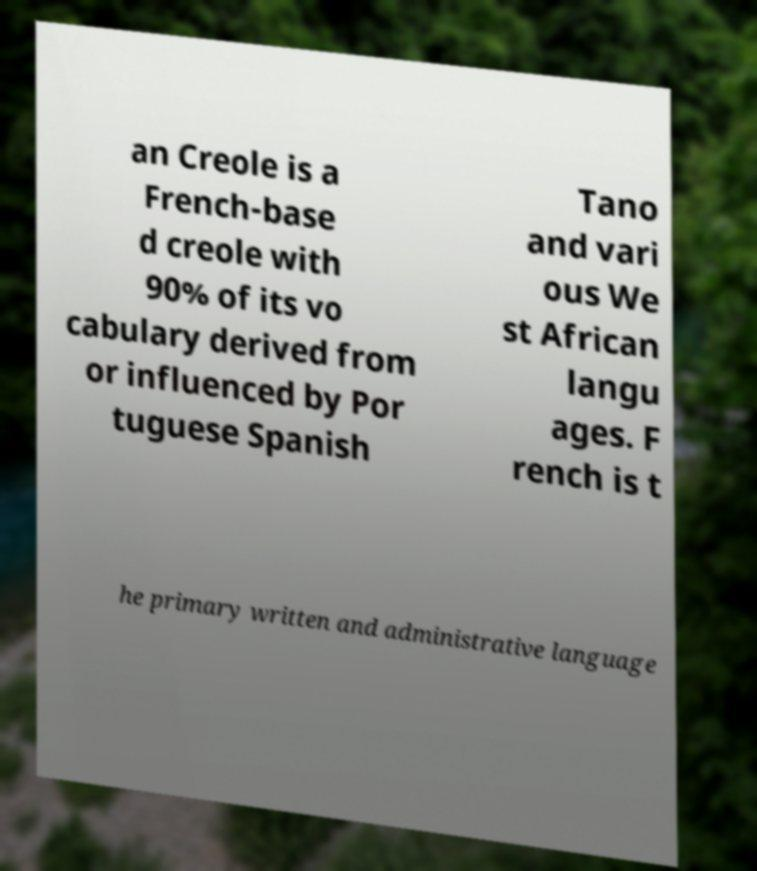Could you assist in decoding the text presented in this image and type it out clearly? an Creole is a French-base d creole with 90% of its vo cabulary derived from or influenced by Por tuguese Spanish Tano and vari ous We st African langu ages. F rench is t he primary written and administrative language 